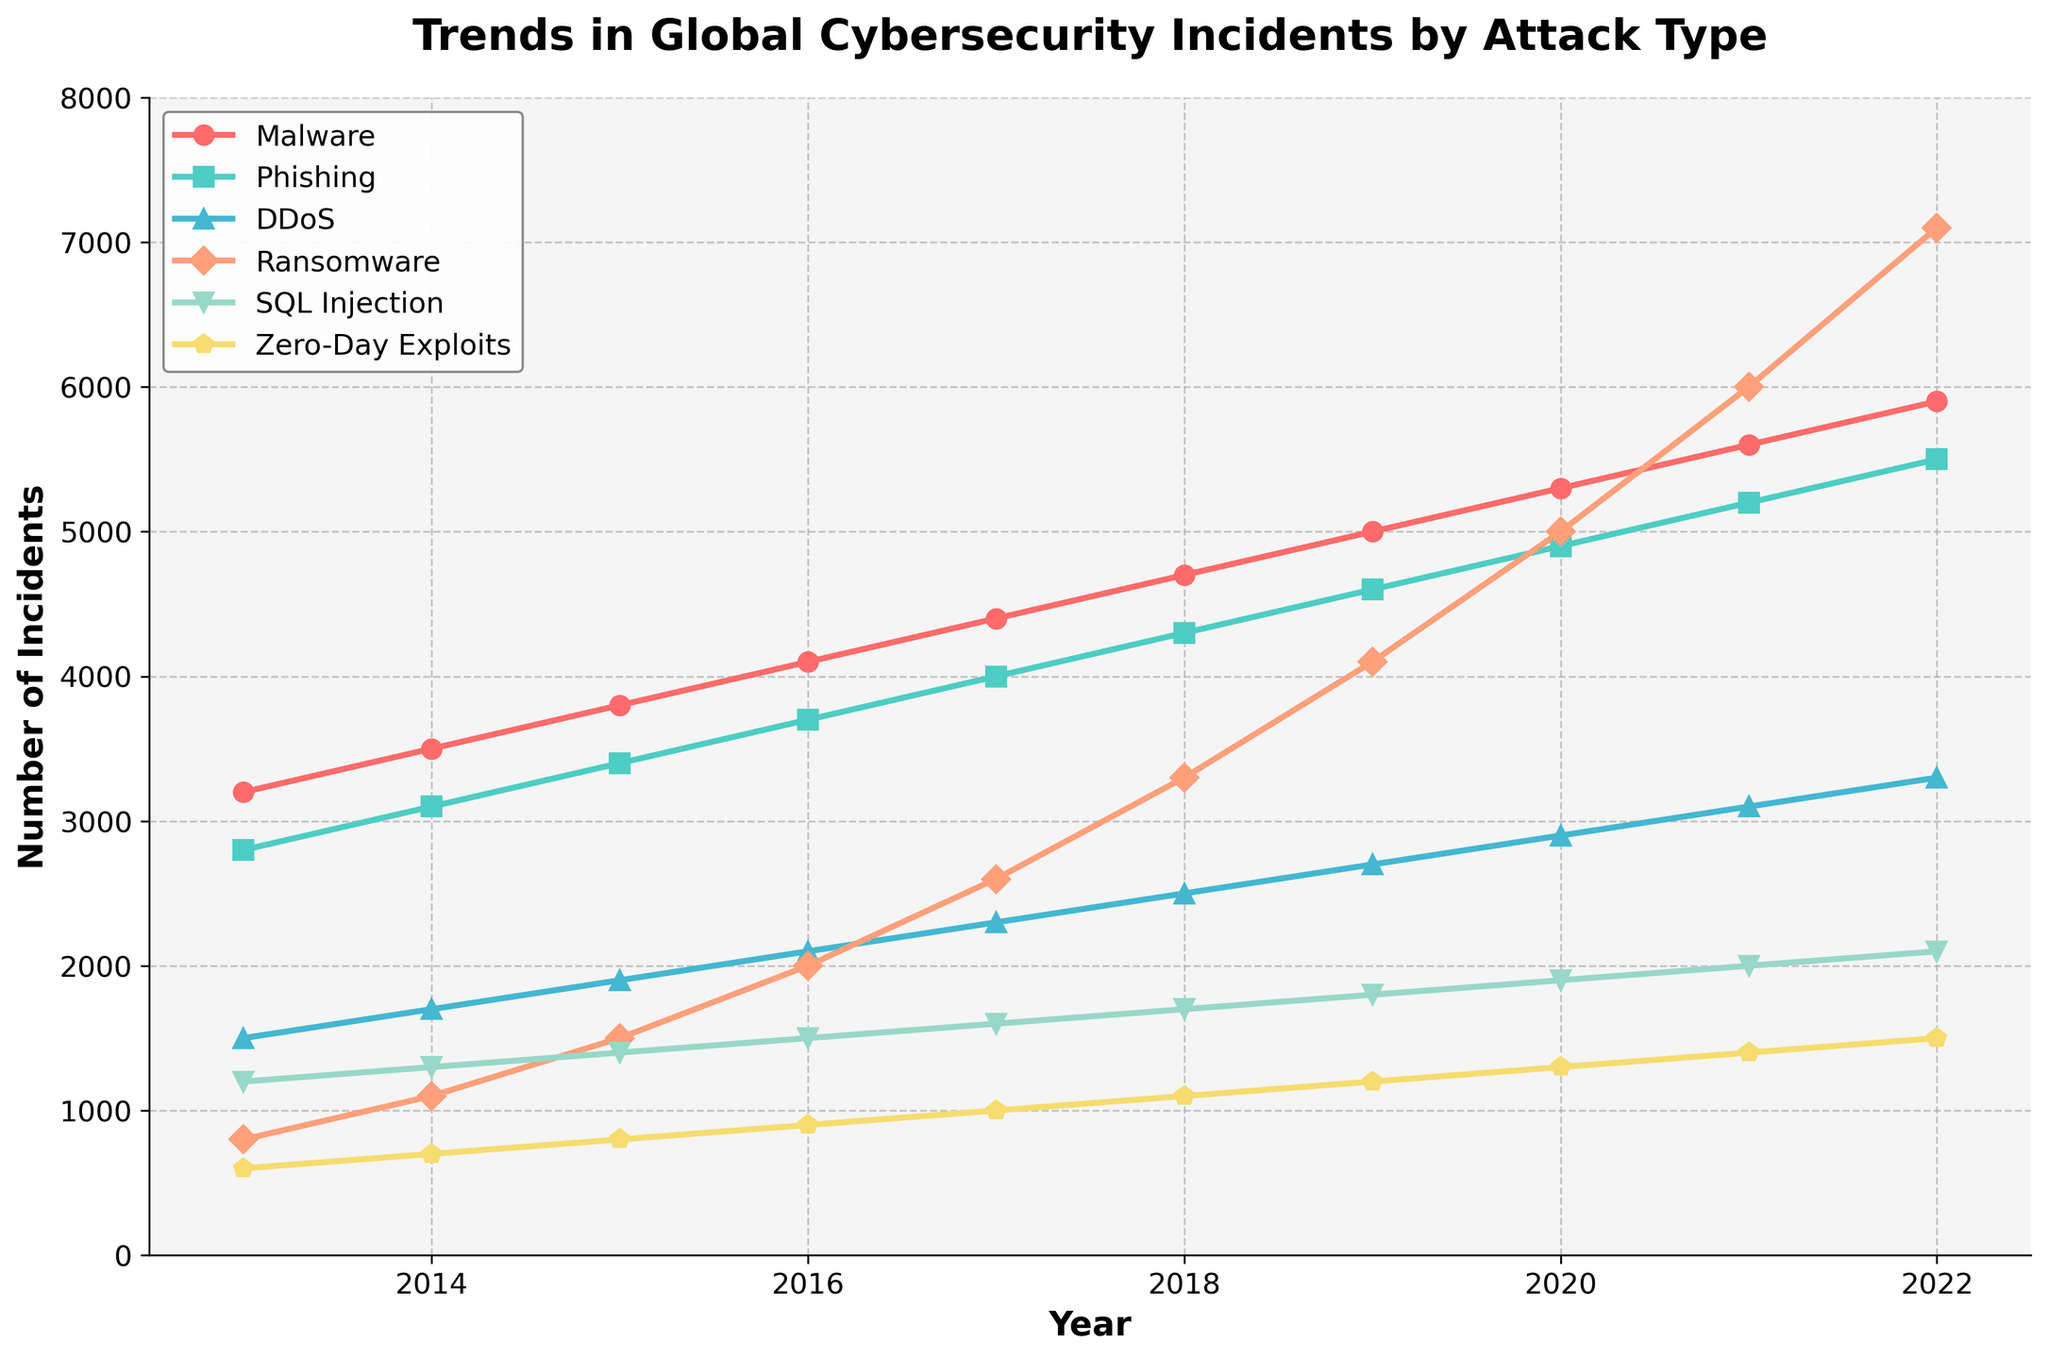what is the overall trend in global cybersecurity incidents from 2013 to 2022 for Malware? To determine the overall trend, we need to compare the number of Malware incidents at the start (2013) and at the end (2022). In 2013, there were 3200 incidents, and in 2022, there were 5900 incidents. There is a clear increase in the number of incidents over the period.
Answer: Increasing Which attack type had the most significant rise in incidents from 2016 to 2022? We compare the number of incidents for each attack type between 2016 and 2022. The difference for Malware is 5900 - 4100 = 1800, for Phishing is 5500 - 3700 = 1800, for DDoS is 3300 - 2100 = 1200, for Ransomware is 7100 - 2000 = 5100, for SQL Injection is 2100 - 1500 = 600, and for Zero-Day Exploits is 1500 - 900 = 600. The most significant rise is in Ransomware.
Answer: Ransomware What is the average number of phishing incidents per year between 2013 and 2022? Sum the number of phishing incidents from 2013 to 2022 and then divide by the total number of years (10). The total is 2800+3100+3400+3700+4000+4300+4600+4900+5200+5500 = 41500. The average is 41500/10 = 4150.
Answer: 4150 Between Phishing and SQL Injection, which had fewer incidents in 2017? By comparing the numbers for 2017, Phishing had 4000 incidents while SQL Injection had 1600 incidents. SQL Injection had fewer incidents.
Answer: SQL Injection What year did Ransomware incidents surpass 5000 for the first time? By examining the trend of Ransomware incidents, the first year it surpasses 5000 is in 2020 with 5000 incidents.
Answer: 2020 How is the number of Zero-Day Exploits incidents in 2015 compared to DDoS incidents in the same year? In 2015, Zero-Day Exploits incidents are 800 while DDoS incidents are 1900. Therefore, Zero-Day Exploits incidents are less than DDoS incidents.
Answer: Less than Which two attack types show an upward trend throughout the entire decade without any decline? To find the attack types with continuous rise, identify those without any year-over-year decrease from 2013 to 2022. Malware and Phishing incidents show consistent increases every year.
Answer: Malware and Phishing What is the total number of incidents for Ransomware and SQL Injection in 2022? The incidents for Ransomware in 2022 are 7100 and for SQL Injection are 2100. The total is 7100 + 2100 = 9200.
Answer: 9200 